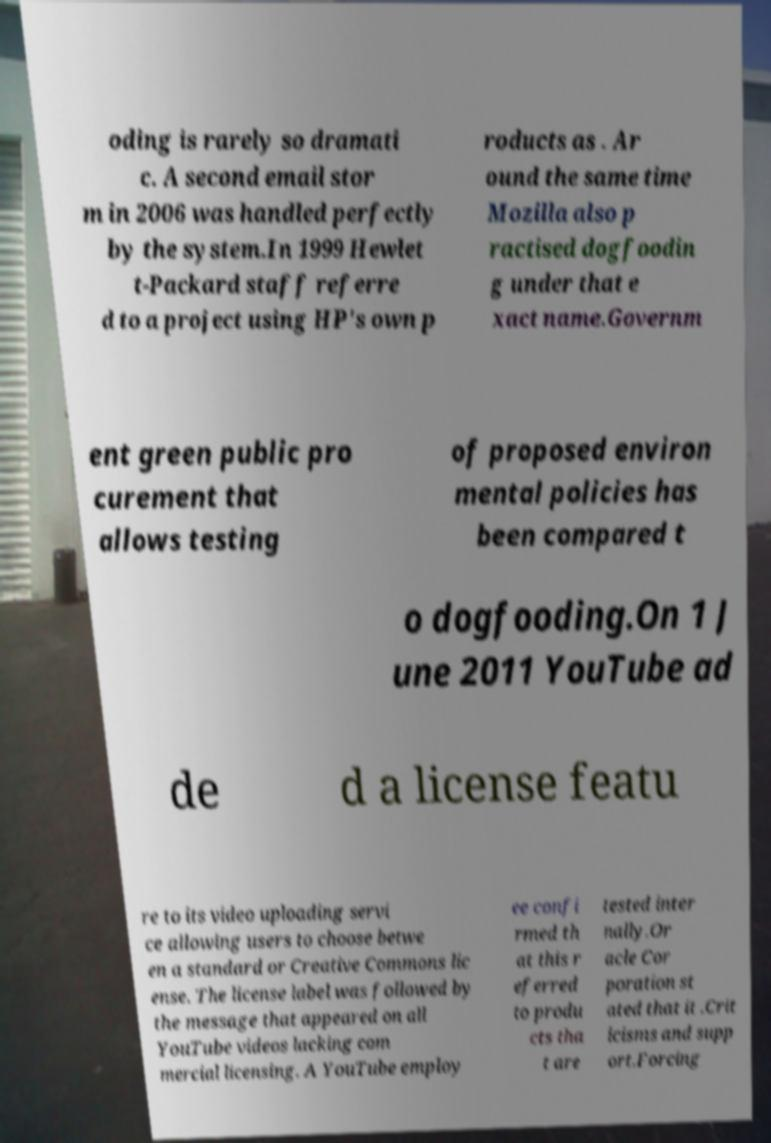Please read and relay the text visible in this image. What does it say? oding is rarely so dramati c. A second email stor m in 2006 was handled perfectly by the system.In 1999 Hewlet t-Packard staff referre d to a project using HP's own p roducts as . Ar ound the same time Mozilla also p ractised dogfoodin g under that e xact name.Governm ent green public pro curement that allows testing of proposed environ mental policies has been compared t o dogfooding.On 1 J une 2011 YouTube ad de d a license featu re to its video uploading servi ce allowing users to choose betwe en a standard or Creative Commons lic ense. The license label was followed by the message that appeared on all YouTube videos lacking com mercial licensing. A YouTube employ ee confi rmed th at this r eferred to produ cts tha t are tested inter nally.Or acle Cor poration st ated that it .Crit icisms and supp ort.Forcing 